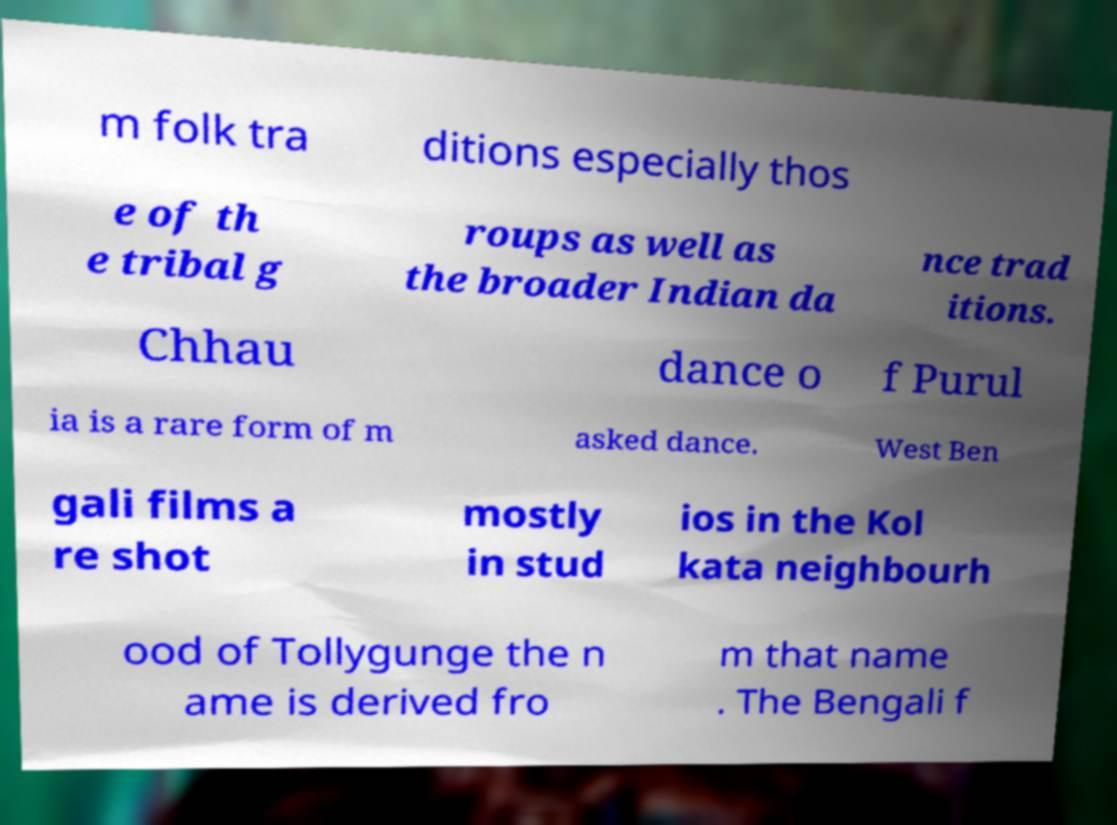For documentation purposes, I need the text within this image transcribed. Could you provide that? m folk tra ditions especially thos e of th e tribal g roups as well as the broader Indian da nce trad itions. Chhau dance o f Purul ia is a rare form of m asked dance. West Ben gali films a re shot mostly in stud ios in the Kol kata neighbourh ood of Tollygunge the n ame is derived fro m that name . The Bengali f 